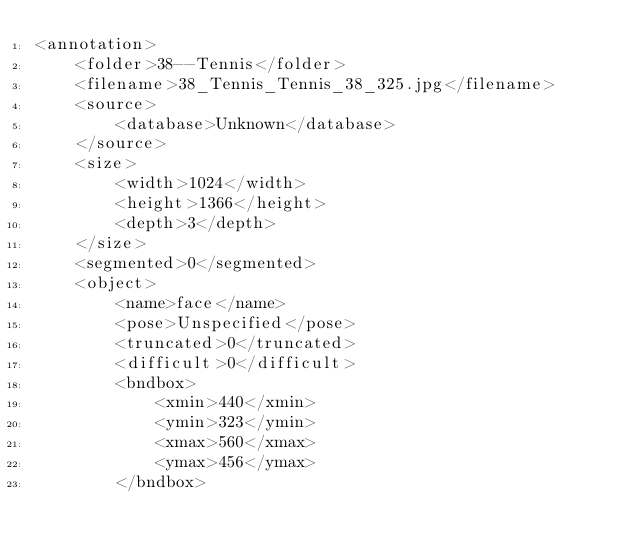<code> <loc_0><loc_0><loc_500><loc_500><_XML_><annotation>
    <folder>38--Tennis</folder>
    <filename>38_Tennis_Tennis_38_325.jpg</filename>
    <source>
        <database>Unknown</database>
    </source>
    <size>
        <width>1024</width>
        <height>1366</height>
        <depth>3</depth>
    </size>
    <segmented>0</segmented>
    <object>
        <name>face</name>
        <pose>Unspecified</pose>
        <truncated>0</truncated>
        <difficult>0</difficult>
        <bndbox>
            <xmin>440</xmin>
            <ymin>323</ymin>
            <xmax>560</xmax>
            <ymax>456</ymax>
        </bndbox></code> 